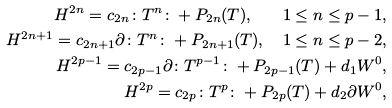Convert formula to latex. <formula><loc_0><loc_0><loc_500><loc_500>H ^ { 2 n } = c _ { 2 n } \colon T ^ { n } \colon + P _ { 2 n } ( T ) , \quad 1 \leq n \leq p - 1 , \\ H ^ { 2 n + 1 } = c _ { 2 n + 1 } \partial \colon T ^ { n } \colon + P _ { 2 n + 1 } ( T ) , \quad 1 \leq n \leq p - 2 , \\ H ^ { 2 p - 1 } = c _ { 2 p - 1 } \partial \colon T ^ { p - 1 } \colon + P _ { 2 p - 1 } ( T ) + d _ { 1 } W ^ { 0 } , \\ H ^ { 2 p } = c _ { 2 p } \colon T ^ { p } \colon + P _ { 2 p } ( T ) + d _ { 2 } \partial W ^ { 0 } ,</formula> 